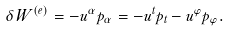Convert formula to latex. <formula><loc_0><loc_0><loc_500><loc_500>\delta W ^ { ( e ) } = - u ^ { \alpha } p _ { \alpha } = - u ^ { t } p _ { t } - u ^ { \varphi } p _ { \varphi } .</formula> 